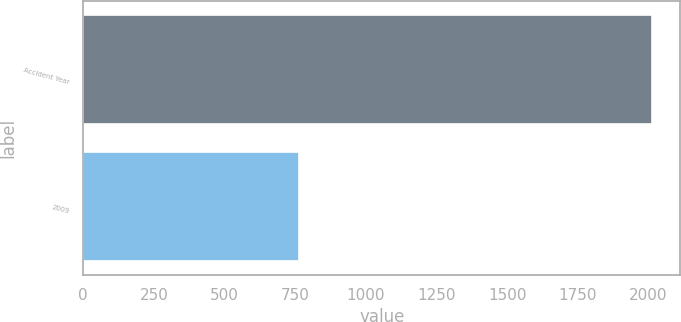Convert chart to OTSL. <chart><loc_0><loc_0><loc_500><loc_500><bar_chart><fcel>Accident Year<fcel>2009<nl><fcel>2013<fcel>763<nl></chart> 